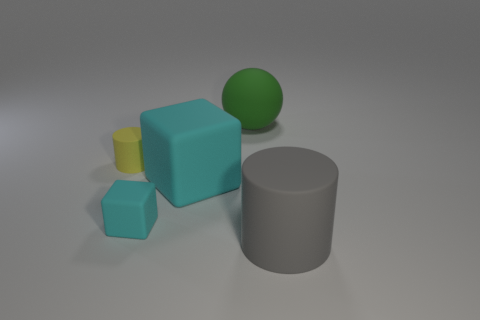Add 5 yellow matte blocks. How many objects exist? 10 Subtract all cylinders. How many objects are left? 3 Subtract 1 cyan blocks. How many objects are left? 4 Subtract all brown matte spheres. Subtract all big green matte spheres. How many objects are left? 4 Add 3 cylinders. How many cylinders are left? 5 Add 5 big yellow balls. How many big yellow balls exist? 5 